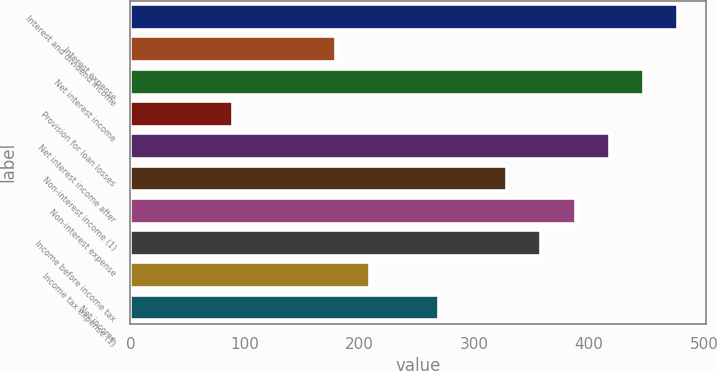<chart> <loc_0><loc_0><loc_500><loc_500><bar_chart><fcel>Interest and dividend income<fcel>Interest expense<fcel>Net interest income<fcel>Provision for loan losses<fcel>Net interest income after<fcel>Non-interest income (1)<fcel>Non-interest expense<fcel>Income before income tax<fcel>Income tax expense (1)<fcel>Net income<nl><fcel>477.77<fcel>179.27<fcel>447.92<fcel>89.72<fcel>418.07<fcel>328.52<fcel>388.22<fcel>358.37<fcel>209.12<fcel>268.82<nl></chart> 